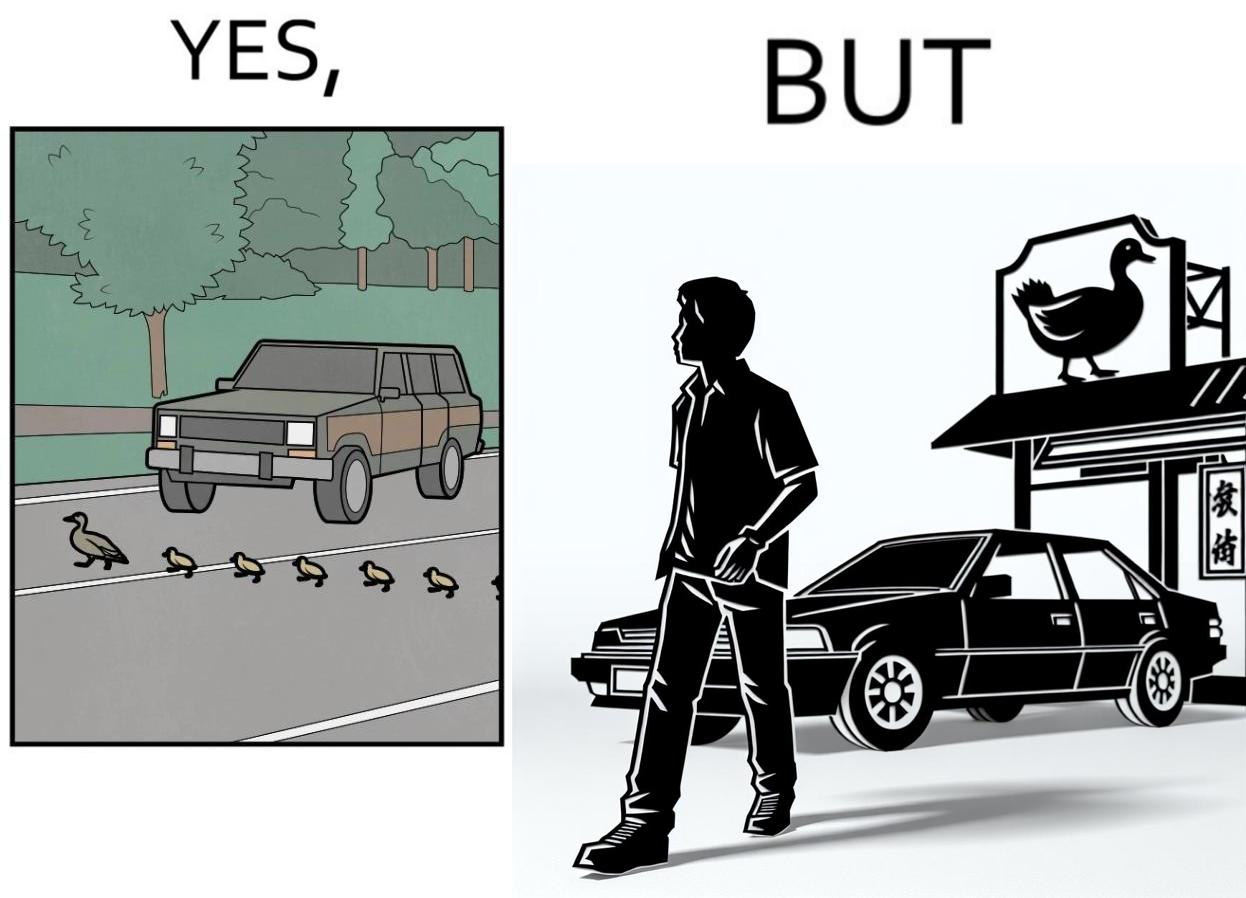Describe the contrast between the left and right parts of this image. In the left part of the image: It is a car stopping to give way to queue of ducks crossing the road and allow them to cross safely In the right part of the image: It is a man parking his car and entering a peking duck shop 